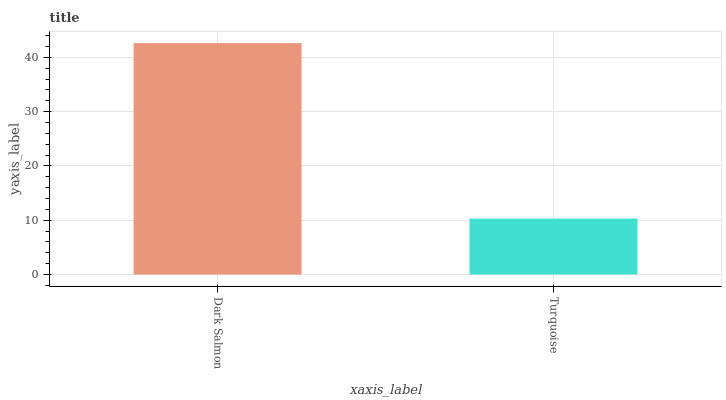Is Turquoise the minimum?
Answer yes or no. Yes. Is Dark Salmon the maximum?
Answer yes or no. Yes. Is Turquoise the maximum?
Answer yes or no. No. Is Dark Salmon greater than Turquoise?
Answer yes or no. Yes. Is Turquoise less than Dark Salmon?
Answer yes or no. Yes. Is Turquoise greater than Dark Salmon?
Answer yes or no. No. Is Dark Salmon less than Turquoise?
Answer yes or no. No. Is Dark Salmon the high median?
Answer yes or no. Yes. Is Turquoise the low median?
Answer yes or no. Yes. Is Turquoise the high median?
Answer yes or no. No. Is Dark Salmon the low median?
Answer yes or no. No. 